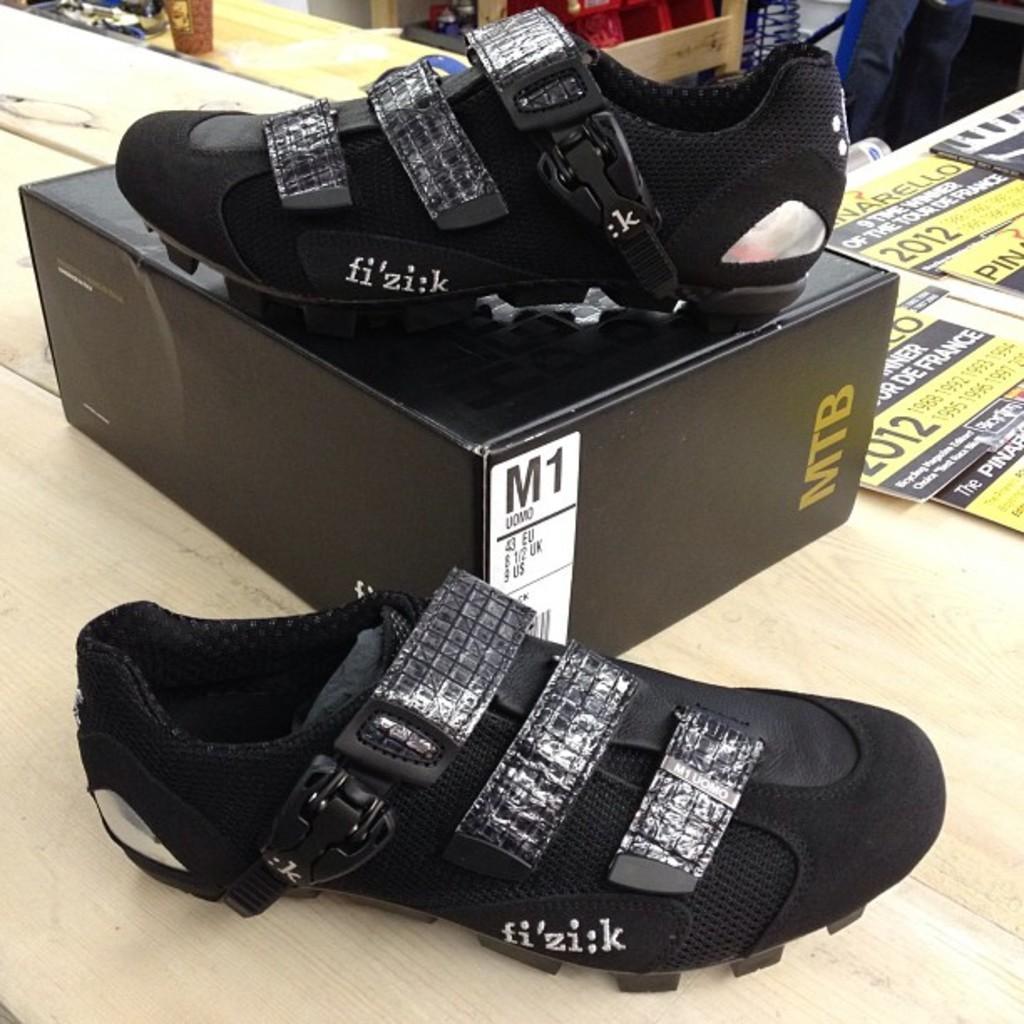Describe this image in one or two sentences. In this image in front there is a table. On top of it there is a box. There are shoes. There are boards with some text and numbers on it. In the background of the image there are a few other objects. 